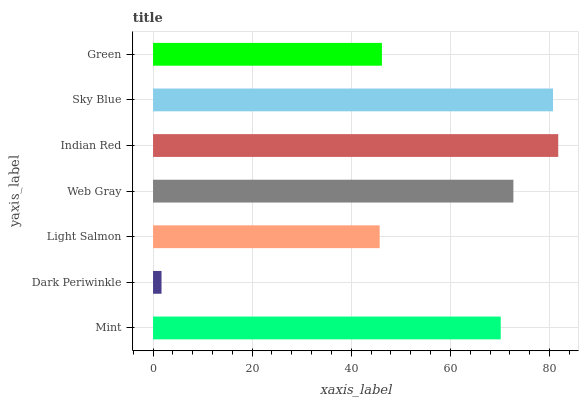Is Dark Periwinkle the minimum?
Answer yes or no. Yes. Is Indian Red the maximum?
Answer yes or no. Yes. Is Light Salmon the minimum?
Answer yes or no. No. Is Light Salmon the maximum?
Answer yes or no. No. Is Light Salmon greater than Dark Periwinkle?
Answer yes or no. Yes. Is Dark Periwinkle less than Light Salmon?
Answer yes or no. Yes. Is Dark Periwinkle greater than Light Salmon?
Answer yes or no. No. Is Light Salmon less than Dark Periwinkle?
Answer yes or no. No. Is Mint the high median?
Answer yes or no. Yes. Is Mint the low median?
Answer yes or no. Yes. Is Green the high median?
Answer yes or no. No. Is Light Salmon the low median?
Answer yes or no. No. 